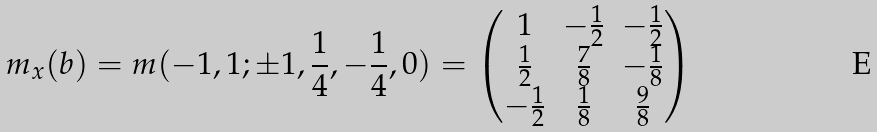Convert formula to latex. <formula><loc_0><loc_0><loc_500><loc_500>m _ { x } ( b ) = m ( - 1 , 1 ; \pm 1 , \frac { 1 } { 4 } , - \frac { 1 } { 4 } , 0 ) = \begin{pmatrix} 1 & - \frac { 1 } { 2 } & - \frac { 1 } { 2 } \\ \frac { 1 } { 2 } & \frac { 7 } { 8 } & - \frac { 1 } { 8 } \\ - \frac { 1 } { 2 } & \frac { 1 } { 8 } & \frac { 9 } { 8 } \end{pmatrix}</formula> 